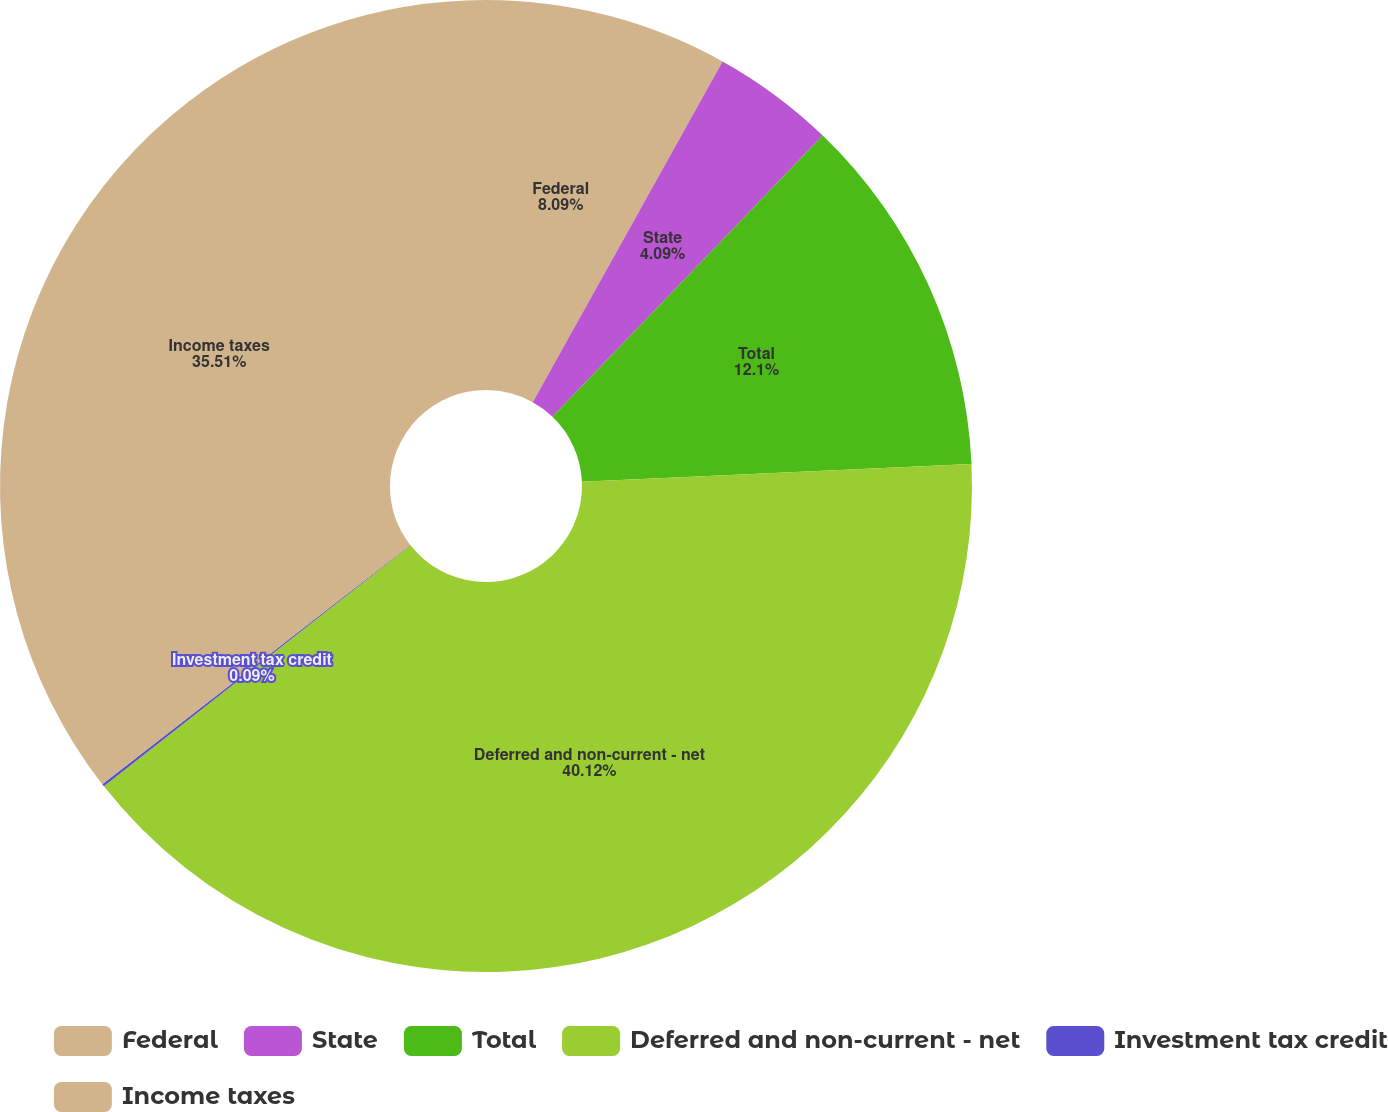Convert chart to OTSL. <chart><loc_0><loc_0><loc_500><loc_500><pie_chart><fcel>Federal<fcel>State<fcel>Total<fcel>Deferred and non-current - net<fcel>Investment tax credit<fcel>Income taxes<nl><fcel>8.09%<fcel>4.09%<fcel>12.1%<fcel>40.11%<fcel>0.09%<fcel>35.51%<nl></chart> 